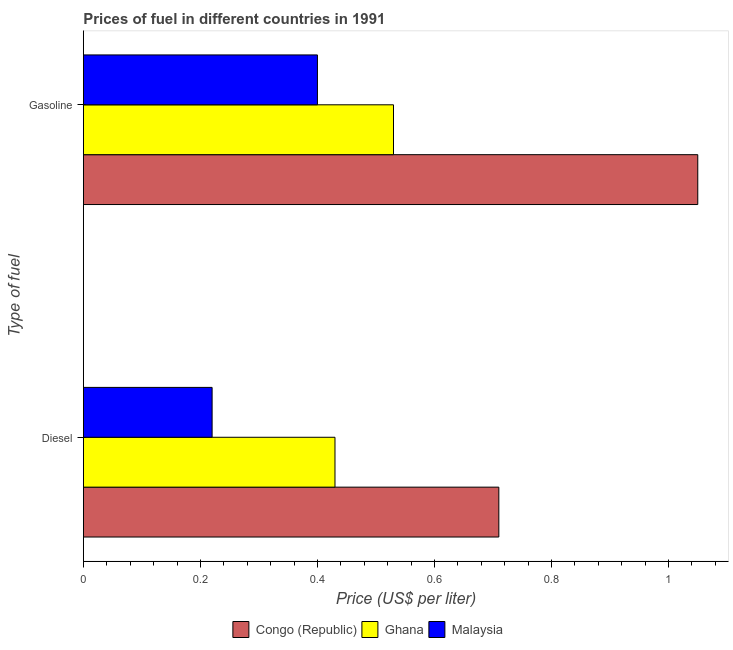How many different coloured bars are there?
Make the answer very short. 3. How many groups of bars are there?
Provide a short and direct response. 2. How many bars are there on the 2nd tick from the top?
Keep it short and to the point. 3. How many bars are there on the 1st tick from the bottom?
Provide a short and direct response. 3. What is the label of the 1st group of bars from the top?
Keep it short and to the point. Gasoline. What is the diesel price in Ghana?
Provide a short and direct response. 0.43. Across all countries, what is the minimum diesel price?
Provide a succinct answer. 0.22. In which country was the diesel price maximum?
Give a very brief answer. Congo (Republic). In which country was the gasoline price minimum?
Provide a short and direct response. Malaysia. What is the total gasoline price in the graph?
Provide a succinct answer. 1.98. What is the difference between the diesel price in Ghana and that in Congo (Republic)?
Ensure brevity in your answer.  -0.28. What is the difference between the diesel price in Malaysia and the gasoline price in Ghana?
Provide a short and direct response. -0.31. What is the average diesel price per country?
Offer a terse response. 0.45. What is the difference between the gasoline price and diesel price in Ghana?
Your response must be concise. 0.1. What is the ratio of the diesel price in Ghana to that in Congo (Republic)?
Your answer should be compact. 0.61. Is the gasoline price in Congo (Republic) less than that in Malaysia?
Offer a very short reply. No. What does the 3rd bar from the top in Diesel represents?
Offer a very short reply. Congo (Republic). What does the 1st bar from the bottom in Gasoline represents?
Provide a succinct answer. Congo (Republic). How many bars are there?
Your answer should be compact. 6. Are all the bars in the graph horizontal?
Give a very brief answer. Yes. Are the values on the major ticks of X-axis written in scientific E-notation?
Offer a very short reply. No. Where does the legend appear in the graph?
Offer a terse response. Bottom center. How many legend labels are there?
Ensure brevity in your answer.  3. How are the legend labels stacked?
Offer a very short reply. Horizontal. What is the title of the graph?
Offer a terse response. Prices of fuel in different countries in 1991. What is the label or title of the X-axis?
Keep it short and to the point. Price (US$ per liter). What is the label or title of the Y-axis?
Your answer should be very brief. Type of fuel. What is the Price (US$ per liter) in Congo (Republic) in Diesel?
Offer a terse response. 0.71. What is the Price (US$ per liter) in Ghana in Diesel?
Ensure brevity in your answer.  0.43. What is the Price (US$ per liter) of Malaysia in Diesel?
Keep it short and to the point. 0.22. What is the Price (US$ per liter) in Ghana in Gasoline?
Make the answer very short. 0.53. What is the Price (US$ per liter) of Malaysia in Gasoline?
Give a very brief answer. 0.4. Across all Type of fuel, what is the maximum Price (US$ per liter) in Congo (Republic)?
Offer a terse response. 1.05. Across all Type of fuel, what is the maximum Price (US$ per liter) of Ghana?
Provide a short and direct response. 0.53. Across all Type of fuel, what is the minimum Price (US$ per liter) of Congo (Republic)?
Offer a terse response. 0.71. Across all Type of fuel, what is the minimum Price (US$ per liter) of Ghana?
Provide a succinct answer. 0.43. Across all Type of fuel, what is the minimum Price (US$ per liter) in Malaysia?
Ensure brevity in your answer.  0.22. What is the total Price (US$ per liter) of Congo (Republic) in the graph?
Keep it short and to the point. 1.76. What is the total Price (US$ per liter) of Ghana in the graph?
Offer a terse response. 0.96. What is the total Price (US$ per liter) of Malaysia in the graph?
Provide a short and direct response. 0.62. What is the difference between the Price (US$ per liter) in Congo (Republic) in Diesel and that in Gasoline?
Keep it short and to the point. -0.34. What is the difference between the Price (US$ per liter) of Ghana in Diesel and that in Gasoline?
Your response must be concise. -0.1. What is the difference between the Price (US$ per liter) of Malaysia in Diesel and that in Gasoline?
Offer a terse response. -0.18. What is the difference between the Price (US$ per liter) of Congo (Republic) in Diesel and the Price (US$ per liter) of Ghana in Gasoline?
Ensure brevity in your answer.  0.18. What is the difference between the Price (US$ per liter) of Congo (Republic) in Diesel and the Price (US$ per liter) of Malaysia in Gasoline?
Provide a succinct answer. 0.31. What is the average Price (US$ per liter) of Congo (Republic) per Type of fuel?
Offer a terse response. 0.88. What is the average Price (US$ per liter) of Ghana per Type of fuel?
Keep it short and to the point. 0.48. What is the average Price (US$ per liter) in Malaysia per Type of fuel?
Offer a very short reply. 0.31. What is the difference between the Price (US$ per liter) of Congo (Republic) and Price (US$ per liter) of Ghana in Diesel?
Give a very brief answer. 0.28. What is the difference between the Price (US$ per liter) in Congo (Republic) and Price (US$ per liter) in Malaysia in Diesel?
Your answer should be very brief. 0.49. What is the difference between the Price (US$ per liter) of Ghana and Price (US$ per liter) of Malaysia in Diesel?
Provide a succinct answer. 0.21. What is the difference between the Price (US$ per liter) in Congo (Republic) and Price (US$ per liter) in Ghana in Gasoline?
Offer a very short reply. 0.52. What is the difference between the Price (US$ per liter) of Congo (Republic) and Price (US$ per liter) of Malaysia in Gasoline?
Provide a succinct answer. 0.65. What is the difference between the Price (US$ per liter) of Ghana and Price (US$ per liter) of Malaysia in Gasoline?
Your answer should be compact. 0.13. What is the ratio of the Price (US$ per liter) in Congo (Republic) in Diesel to that in Gasoline?
Give a very brief answer. 0.68. What is the ratio of the Price (US$ per liter) of Ghana in Diesel to that in Gasoline?
Give a very brief answer. 0.81. What is the ratio of the Price (US$ per liter) of Malaysia in Diesel to that in Gasoline?
Keep it short and to the point. 0.55. What is the difference between the highest and the second highest Price (US$ per liter) in Congo (Republic)?
Provide a short and direct response. 0.34. What is the difference between the highest and the second highest Price (US$ per liter) in Ghana?
Your answer should be compact. 0.1. What is the difference between the highest and the second highest Price (US$ per liter) of Malaysia?
Keep it short and to the point. 0.18. What is the difference between the highest and the lowest Price (US$ per liter) in Congo (Republic)?
Offer a very short reply. 0.34. What is the difference between the highest and the lowest Price (US$ per liter) in Malaysia?
Offer a very short reply. 0.18. 